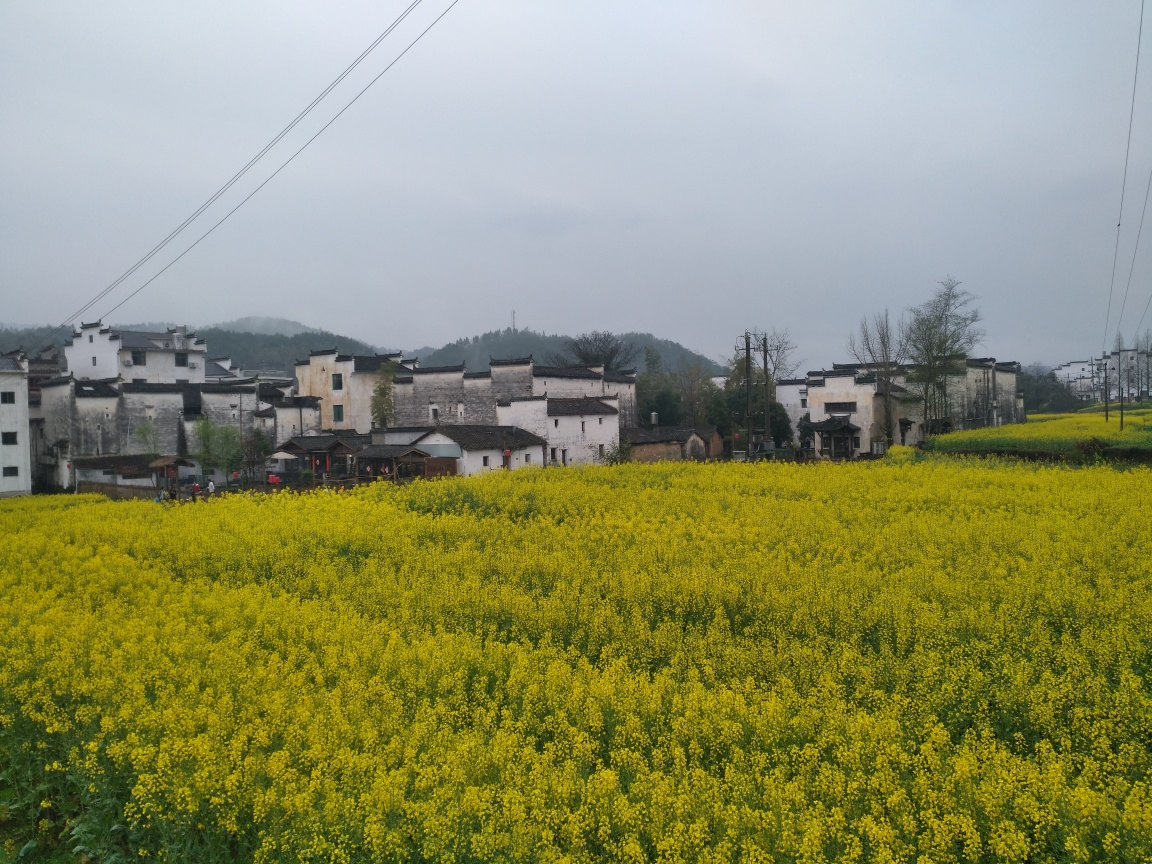What time of year might this photo have been taken? Given the full bloom of the yellow flowers, which could likely be rapeseed blossoms, this photo was probably taken in early spring. This is typically the season when rapeseed flowers are in peak bloom, creating vibrant yellow fields such as the one depicted in the image. 